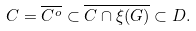Convert formula to latex. <formula><loc_0><loc_0><loc_500><loc_500>C = \overline { C ^ { o } } \subset \overline { C \cap \xi ( G ) } \subset D .</formula> 